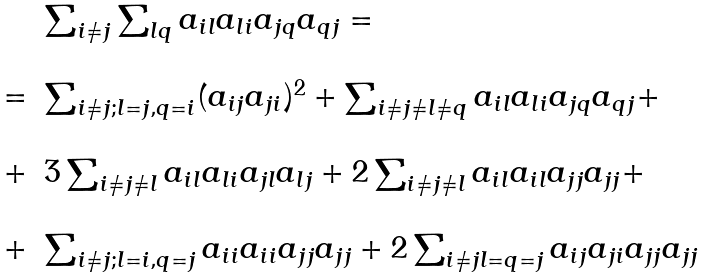<formula> <loc_0><loc_0><loc_500><loc_500>\begin{array} { l c l } & & \sum _ { i \neq j } \sum _ { l q } a _ { i l } a _ { l i } a _ { j q } a _ { q j } = \\ & & \\ & = & \sum _ { i \neq j ; l = j , q = i } ( a _ { i j } a _ { j i } ) ^ { 2 } + \sum _ { i \neq j \neq l \neq q } a _ { i l } a _ { l i } a _ { j q } a _ { q j } + \\ & & \\ & + & 3 \sum _ { i \neq j \neq l } a _ { i l } a _ { l i } a _ { j l } a _ { l j } + 2 \sum _ { i \neq j \neq l } a _ { i l } a _ { i l } a _ { j j } a _ { j j } + \\ & & \\ & + & \sum _ { i \neq j ; l = i , q = j } a _ { i i } a _ { i i } a _ { j j } a _ { j j } + 2 \sum _ { i \neq j l = q = j } a _ { i j } a _ { j i } a _ { j j } a _ { j j } \\ \end{array}</formula> 